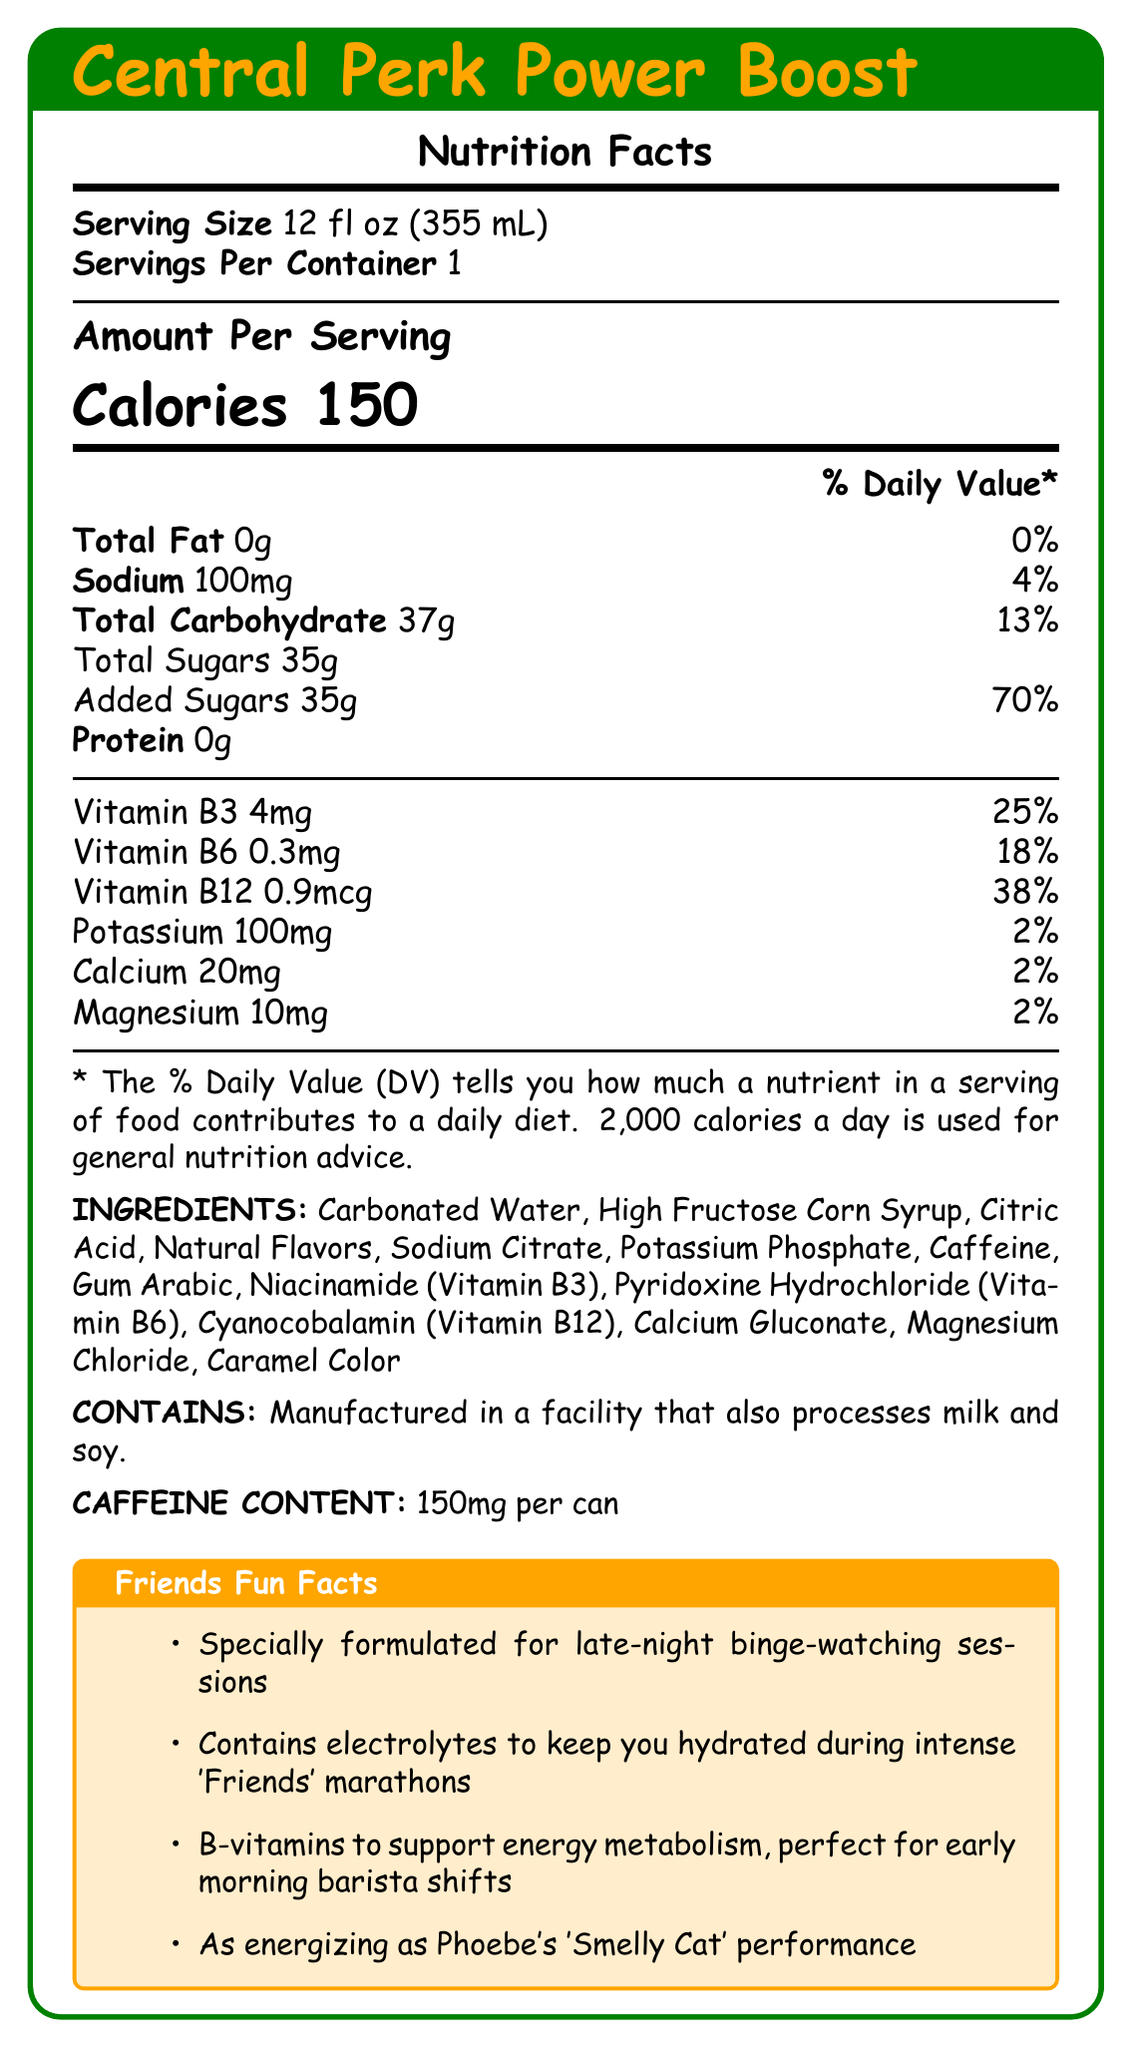what is the product name? The product name is clearly mentioned at the top of the document.
Answer: Central Perk Power Boost how many calories are there per serving? The document specifies that there are 150 calories per serving.
Answer: 150 what is the serving size? The serving size is stated as 12 fl oz (355 mL).
Answer: 12 fl oz (355 mL) how much sodium is there per serving? The sodium content per serving is listed as 100mg.
Answer: 100mg what percentage of daily value of vitamin B12 does one serving provide? The vitamin B12 content per serving is 0.9mcg, which is 38% of the daily value.
Answer: 38% what are the electrolytes present in the drink? The drink contains sodium (100mg), potassium (100mg), calcium (20mg), and magnesium (10mg), all of which are electrolytes.
Answer: Sodium, Potassium, Calcium, Magnesium what is the main ingredient in the drink? A. High Fructose Corn Syrup B. Carbonated Water C. Caffeine D. Citric Acid The first listed ingredient is Carbonated Water.
Answer: B what is the percentage daily value of added sugars? A. 35% B. 50% C. 70% D. 90% The document states that the daily value of added sugars (35g) is 70%.
Answer: C is this drink suitable for someone trying to reduce their sodium intake? Yes/No The drink contains 100mg of sodium, which might not be suitable for someone trying to reduce their sodium intake.
Answer: No summarize the main features and claims of the Central Perk Power Boost energy drink. This product claims to provide energy and hydration through its formulation of electrolytes and B-vitamins, with a theme inspired by the sitcom Friends. It highlights specific benefits for late nights and early mornings, making it particularly suitable for fans of the show.
Answer: The Central Perk Power Boost is a Friends-themed energy drink with 150 calories per serving. It contains electrolytes (sodium, potassium, calcium, and magnesium) and B-vitamins (B3, B6, and B12) to support hydration and energy metabolism. It is specially formulated for late-night binge-watching sessions and early morning shifts. It carries fun marketing claims related to the sitcom Friends and contains 150mg of caffeine per can. what is the amount of caffeine per can? The caffeine content is listed as 150mg per can.
Answer: 150mg how much vitamin B3 is in the drink? The document lists the vitamin B3 content as 4mg.
Answer: 4mg does the drink contain any protein? The drink contains 0g of protein.
Answer: No is the vitamin B6 content high or low compared to the daily value percentage? The vitamin B6 content is 0.3mg, which is only 18% of the daily value, indicating a relatively low contribution.
Answer: Low which of these is not listed as an ingredient in the drink? A. Sodium Citrate B. Ascorbic Acid C. Potassium Phosphate D. Gum Arabic Ascorbic Acid is not listed as an ingredient in the drink.
Answer: B in which type of facility is the drink manufactured? The allergen information states the drink is manufactured in a facility that processes milk and soy.
Answer: A facility that also processes milk and soy. how much total carbohydrate is in the drink? The document states the total carbohydrate content is 37g.
Answer: 37g can you determine the specific flavor of the drink from the document? The document lists "Natural Flavors" but does not specify the exact flavor of the drink.
Answer: Not enough information 